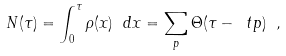Convert formula to latex. <formula><loc_0><loc_0><loc_500><loc_500>N ( \tau ) = \int _ { 0 } ^ { \tau } \rho ( x ) \ d x = \sum _ { p } \Theta ( \tau - \ t p ) \ ,</formula> 